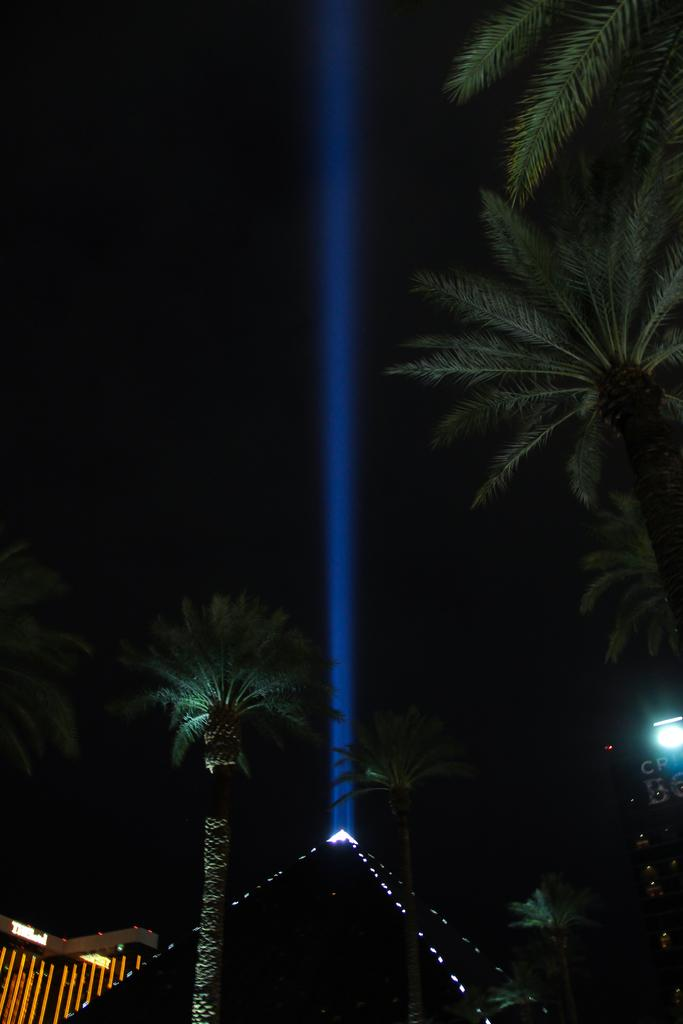What structure is located on the left side of the image? There is a building on the left side of the image. What type of natural elements can be seen in the image? Trees are present in the image. What can be seen on the right side of the image? Lights are visible on the right side of the image. What part of the natural environment is visible in the image? The sky is present in the image, specifically on the right side. Can you tell me how many bubbles are floating near the building in the image? There are no bubbles present in the image; it features a building, trees, lights, and the sky. What type of seed is growing on the trees in the image? There is no mention of seeds or specific tree types in the image, only trees in general. 